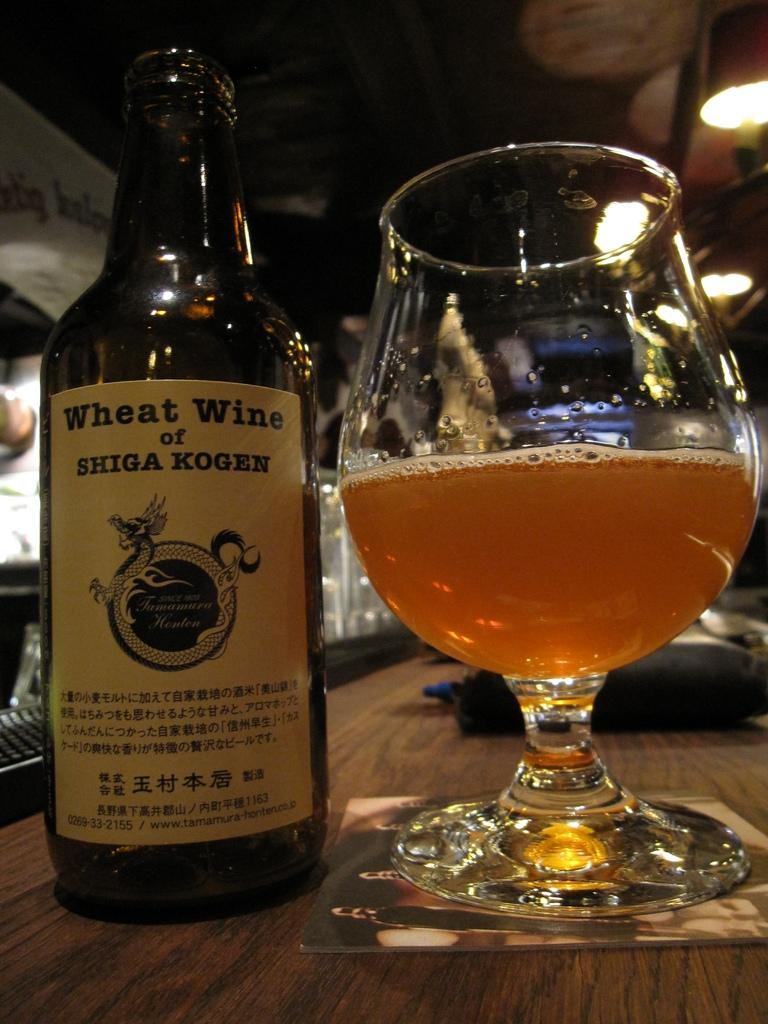<image>
Give a short and clear explanation of the subsequent image. A large glass next to a bottle of wheat wine. 